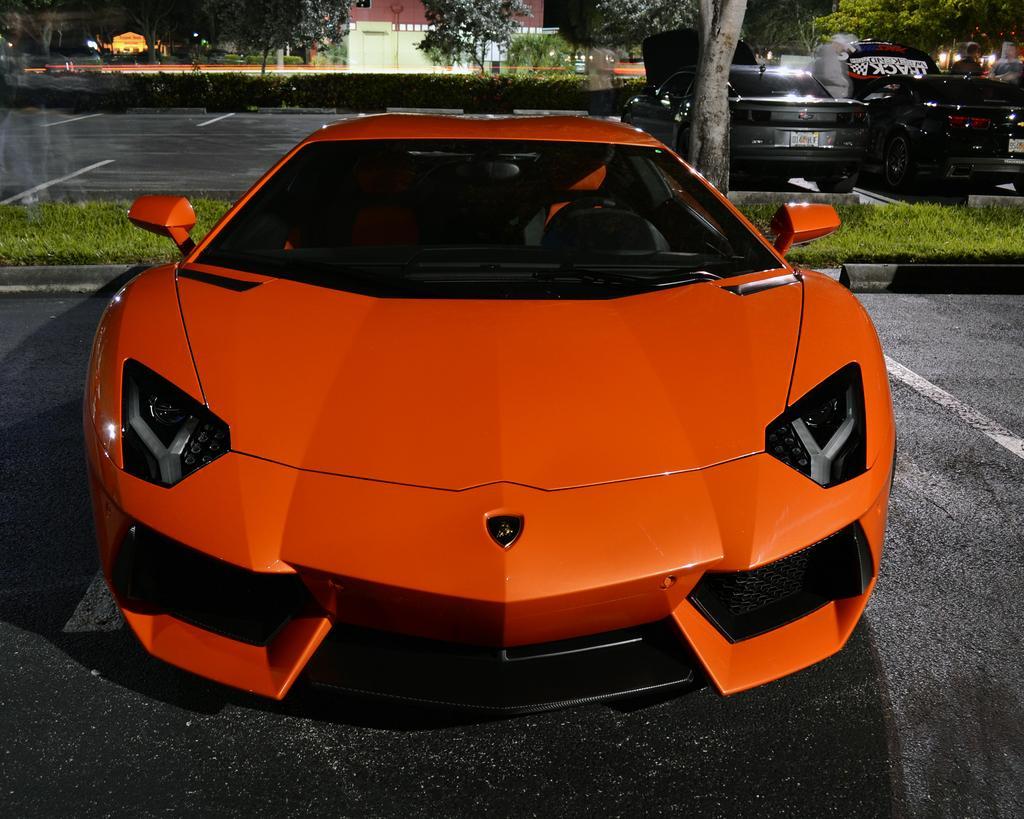Please provide a concise description of this image. In the center of the image we can see a car which is in orange color. At the bottom there is a road. On the right there are cars, trees. In the background there is a building. 